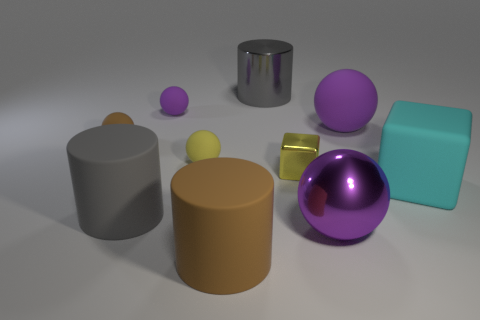Subtract all green cubes. How many purple spheres are left? 3 Subtract all brown balls. How many balls are left? 4 Subtract all big purple metallic spheres. How many spheres are left? 4 Subtract all brown spheres. Subtract all gray blocks. How many spheres are left? 4 Subtract all cylinders. How many objects are left? 7 Subtract 0 blue spheres. How many objects are left? 10 Subtract all big brown objects. Subtract all tiny purple balls. How many objects are left? 8 Add 9 tiny yellow blocks. How many tiny yellow blocks are left? 10 Add 6 tiny metallic objects. How many tiny metallic objects exist? 7 